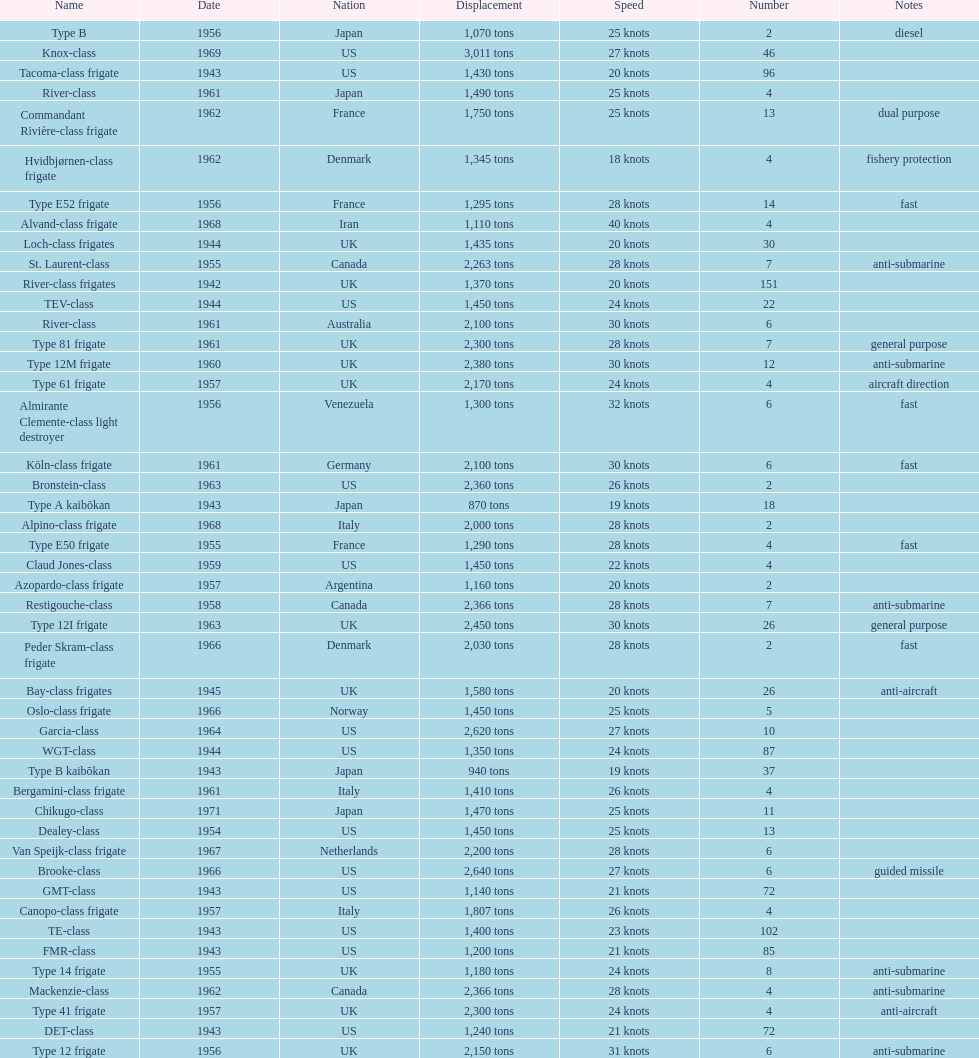What is the displacement of the te-class in tons? 1,400 tons. 